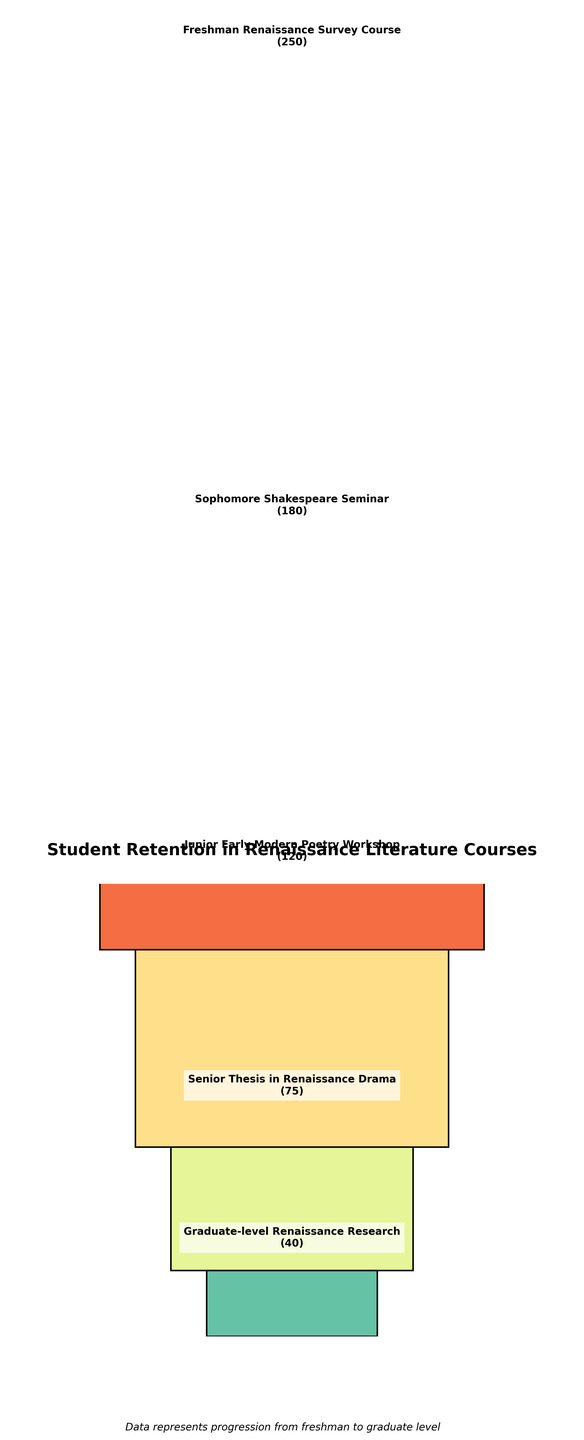what's the total number of students shown in the figure? To find the total number of students, add the student counts for each stage: 250 (Freshman) + 180 (Sophomore) + 120 (Junior) + 75 (Senior) + 40 (Graduate) = 665
Answer: 665 which stage has the highest number of students? Look at the heights of the bars in the chart. The Freshman course has the highest bar, indicating the most students.
Answer: Freshman Renaissance Survey Course how many students transition from the Sophomore Shakespeare Seminar to the Junior Early Modern Poetry Workshop? Subtract the number of Junior students from Sophomore students: 180 (Sophomore) - 120 (Junior) = 60
Answer: 60 what percentage of Freshman students advance to the Sophomore stage? Divide the number of Sophomore students by Freshman students and multiply by 100: (180 / 250) * 100 = 72%
Answer: 72% what's the rate of decline from Junior Early Modern Poetry Workshop to Senior Thesis in Renaissance Drama? Subtract the number of Senior students from Junior students, divide by Junior students, and multiply by 100: ((120 - 75) / 120) * 100 = 37.5%
Answer: 37.5% how many more students are there in the Freshman course compared to the Graduate-level course? Subtract the number of Graduate students from Freshman students: 250 (Freshman) - 40 (Graduate) = 210
Answer: 210 which two consecutive stages have the least decline in student numbers? Compare the differences between consecutive stages: Freshman-Sophomore (250-180=70), Sophomore-Junior (180-120=60), Junior-Senior (120-75=45), Senior-Graduate (75-40=35). The smallest decline is between Senior and Graduate stages with a drop of 35 students.
Answer: Senior to Graduate what proportion of the total students reach the Junior year? Divide the number of Junior students by the total number of students and multiply by 100: (120 / 665) * 100 = approximately 18%
Answer: 18% how many students do not continue beyond the Freshman year? Subtract the number of Sophomore students from the number of Freshman students: 250 - 180 = 70
Answer: 70 what's the average number of students per stage? Sum the number of students and divide by the number of stages: (250 + 180 + 120 + 75 + 40) / 5 = 133
Answer: 133 